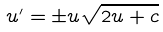Convert formula to latex. <formula><loc_0><loc_0><loc_500><loc_500>u ^ { \prime } = \pm u \sqrt { 2 u + c }</formula> 